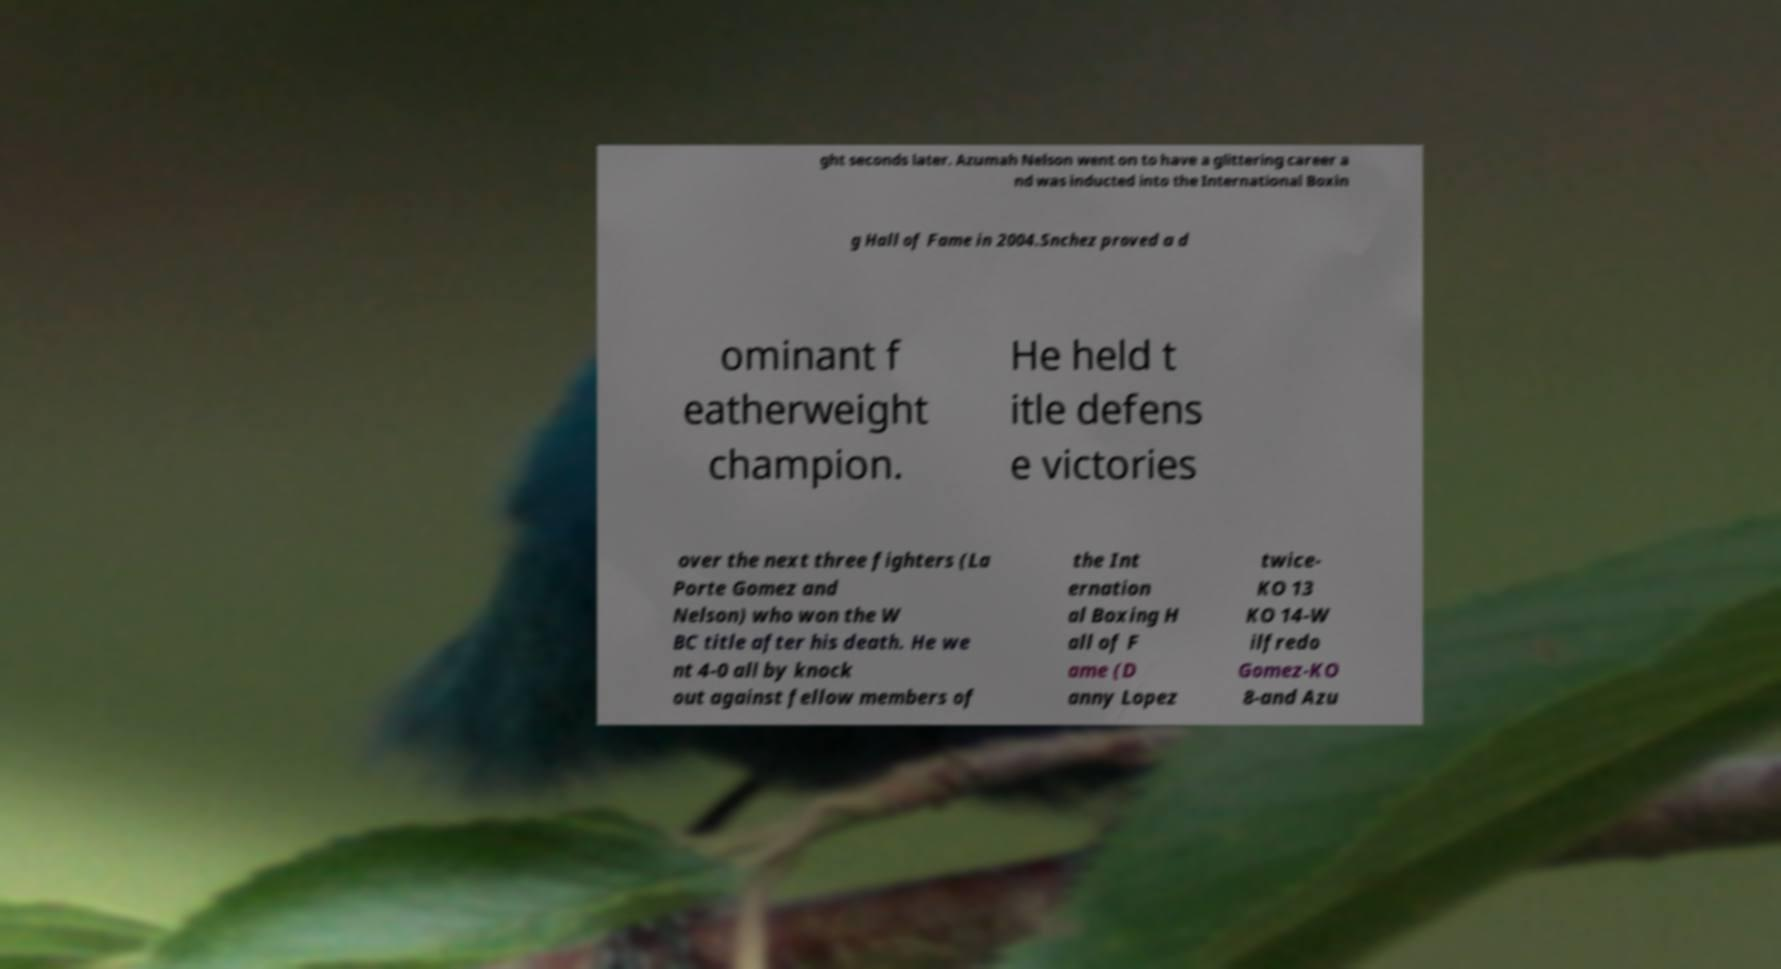Could you extract and type out the text from this image? ght seconds later. Azumah Nelson went on to have a glittering career a nd was inducted into the International Boxin g Hall of Fame in 2004.Snchez proved a d ominant f eatherweight champion. He held t itle defens e victories over the next three fighters (La Porte Gomez and Nelson) who won the W BC title after his death. He we nt 4-0 all by knock out against fellow members of the Int ernation al Boxing H all of F ame (D anny Lopez twice- KO 13 KO 14-W ilfredo Gomez-KO 8-and Azu 